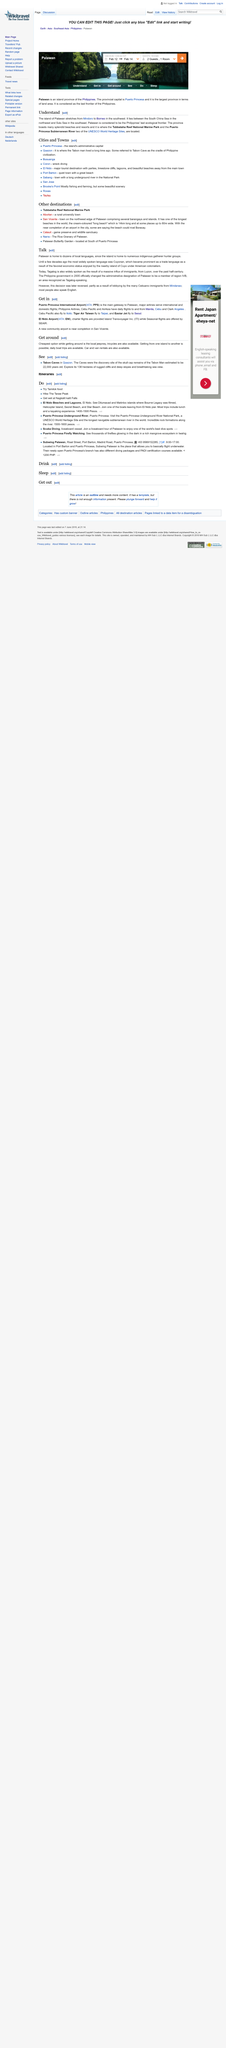Identify some key points in this picture. There are two UNESCO World Heritage Sites located in Palawan: the Tubbataha Reef National Marine Park and the Puerto Princesa Subterranean River National Park. These sites are recognized for their outstanding universal value and are protected for future generations to appreciate and learn from. Palawan is the largest province in terms of land area among all the provinces in the Philippines. Palawan is an island province in the Philippines that is located in the MIMAROPA region. The provincial capital of Palawan is Puerto Princesa. 